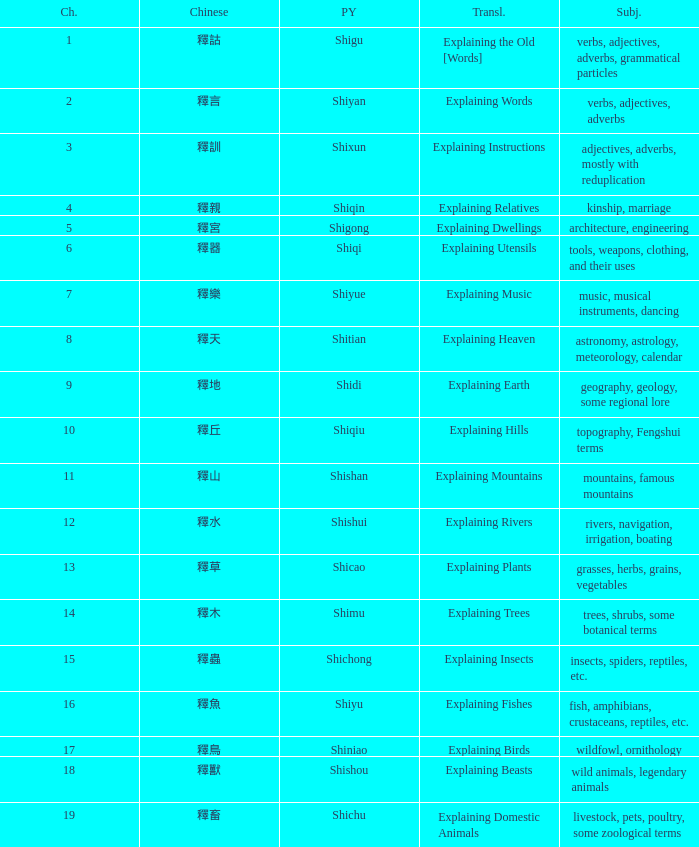Name the chapter with chinese of 釋水 12.0. 